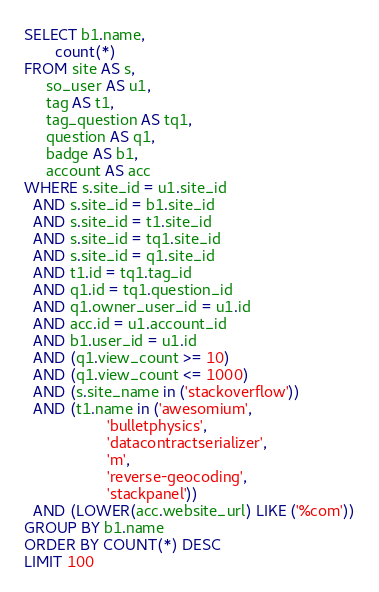Convert code to text. <code><loc_0><loc_0><loc_500><loc_500><_SQL_>SELECT b1.name,
       count(*)
FROM site AS s,
     so_user AS u1,
     tag AS t1,
     tag_question AS tq1,
     question AS q1,
     badge AS b1,
     account AS acc
WHERE s.site_id = u1.site_id
  AND s.site_id = b1.site_id
  AND s.site_id = t1.site_id
  AND s.site_id = tq1.site_id
  AND s.site_id = q1.site_id
  AND t1.id = tq1.tag_id
  AND q1.id = tq1.question_id
  AND q1.owner_user_id = u1.id
  AND acc.id = u1.account_id
  AND b1.user_id = u1.id
  AND (q1.view_count >= 10)
  AND (q1.view_count <= 1000)
  AND (s.site_name in ('stackoverflow'))
  AND (t1.name in ('awesomium',
                   'bulletphysics',
                   'datacontractserializer',
                   'm',
                   'reverse-geocoding',
                   'stackpanel'))
  AND (LOWER(acc.website_url) LIKE ('%com'))
GROUP BY b1.name
ORDER BY COUNT(*) DESC
LIMIT 100</code> 